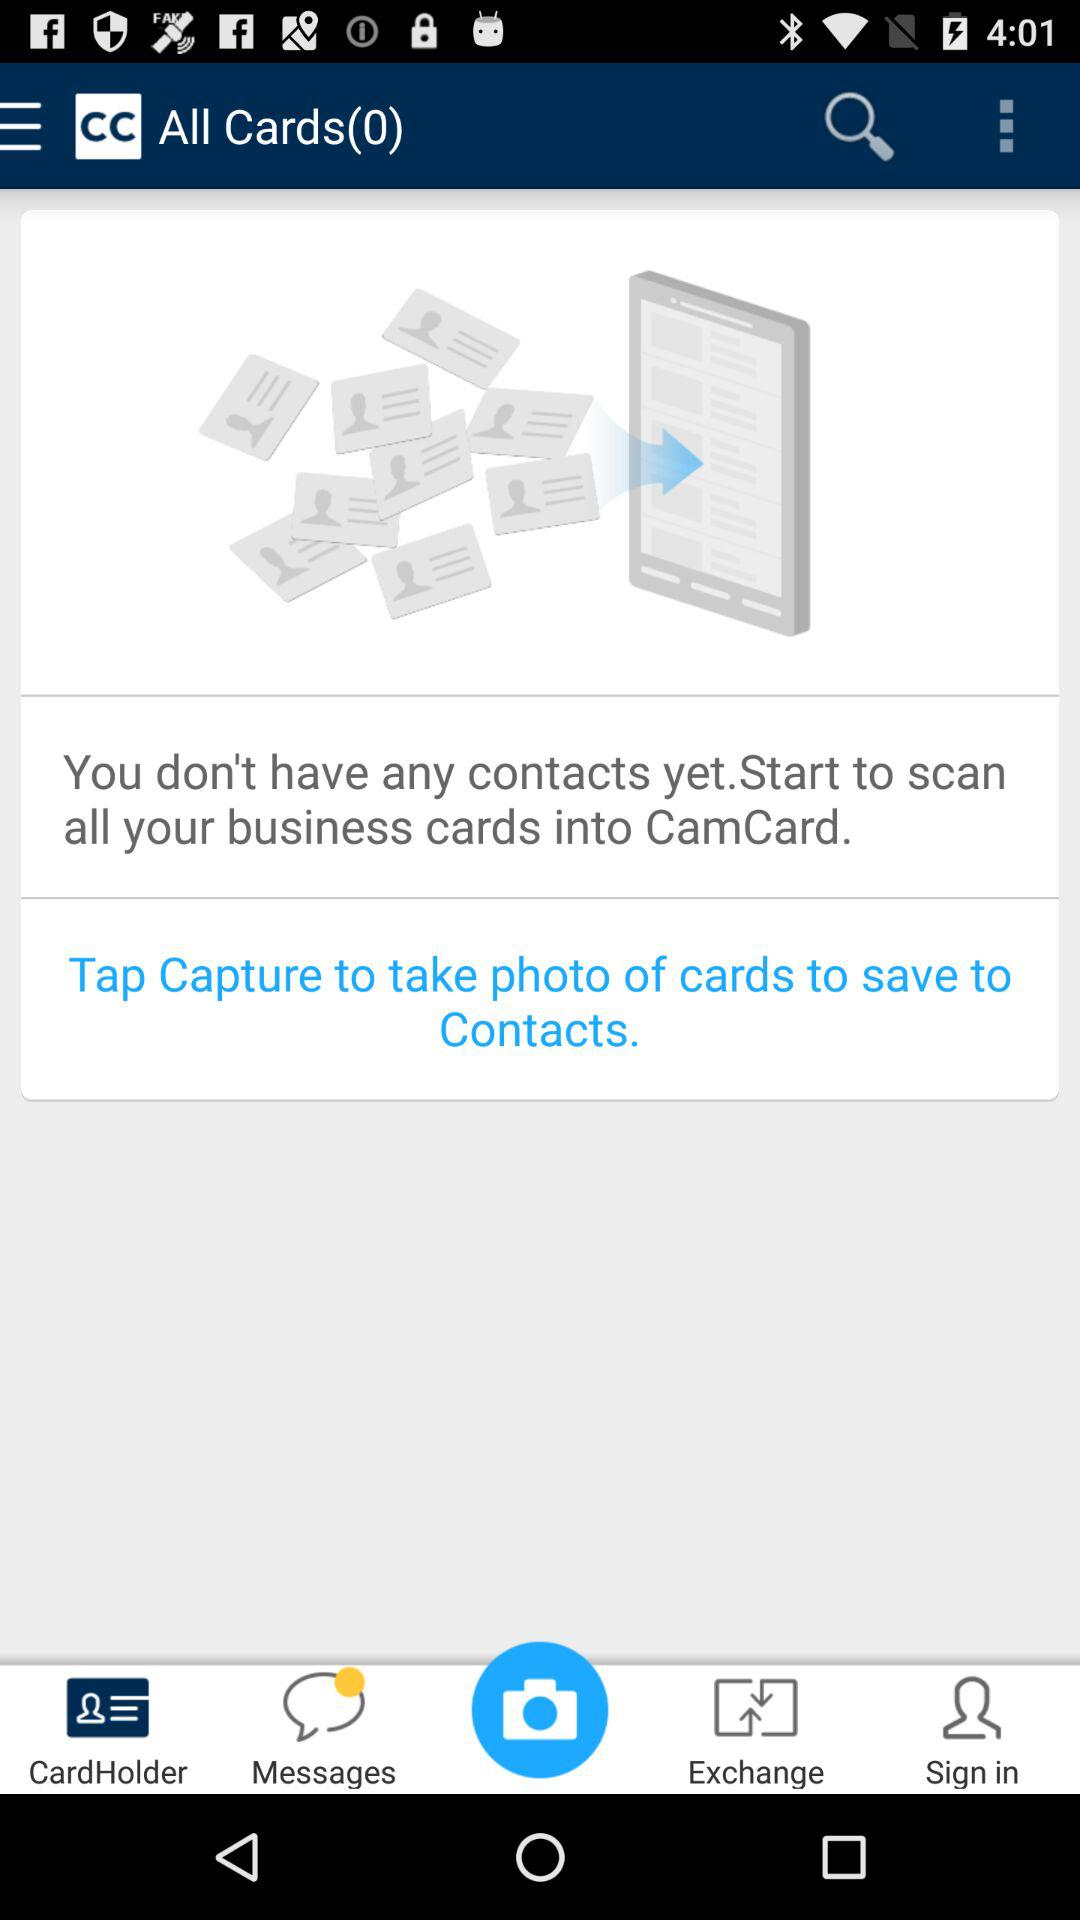How many cards do I have?
Answer the question using a single word or phrase. 0 